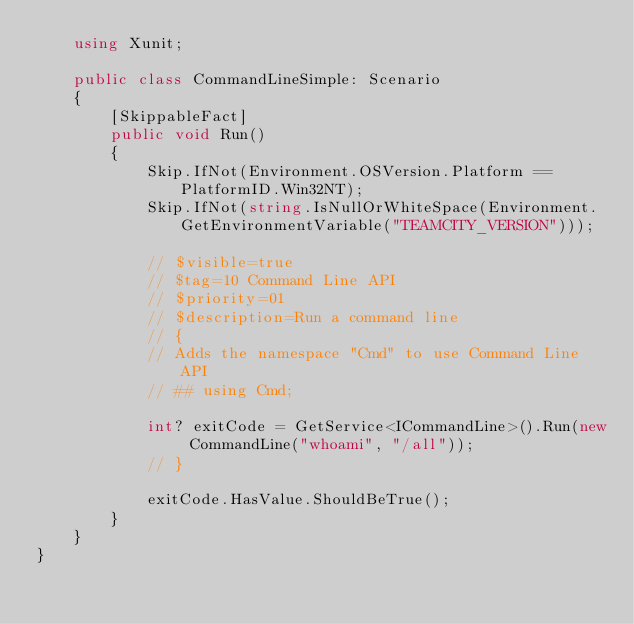<code> <loc_0><loc_0><loc_500><loc_500><_C#_>    using Xunit;

    public class CommandLineSimple: Scenario
    {
        [SkippableFact]
        public void Run()
        {
            Skip.IfNot(Environment.OSVersion.Platform == PlatformID.Win32NT);
            Skip.IfNot(string.IsNullOrWhiteSpace(Environment.GetEnvironmentVariable("TEAMCITY_VERSION")));

            // $visible=true
            // $tag=10 Command Line API
            // $priority=01
            // $description=Run a command line
            // {
            // Adds the namespace "Cmd" to use Command Line API
            // ## using Cmd;

            int? exitCode = GetService<ICommandLine>().Run(new CommandLine("whoami", "/all"));
            // }
            
            exitCode.HasValue.ShouldBeTrue();
        }
    }
}</code> 